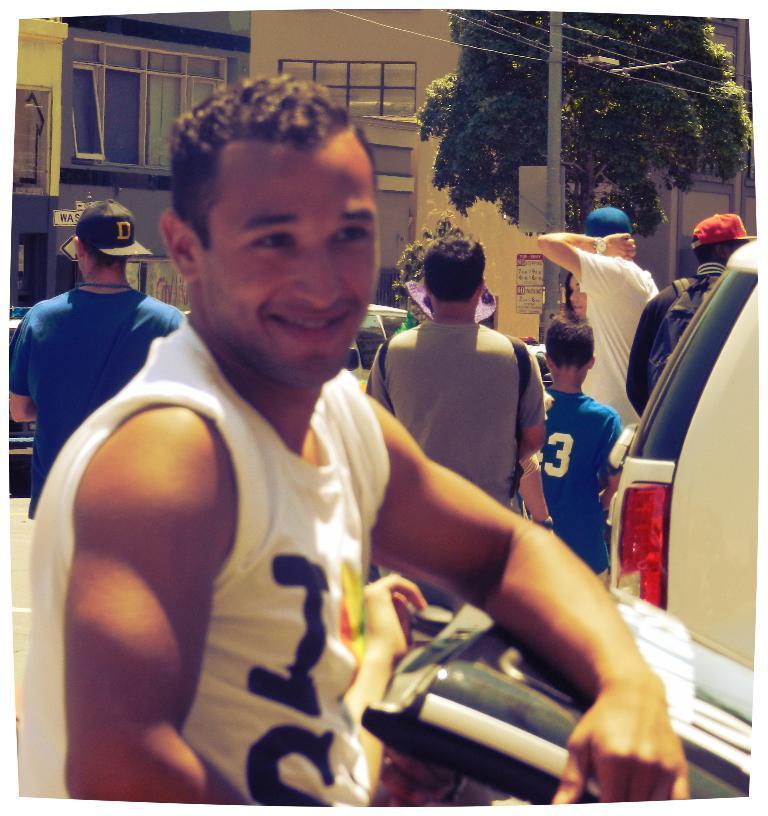Please provide a concise description of this image. In the center of the image there is a person standing on the road. In the background we can see persons, car, tree, pole, wires and buildings. 